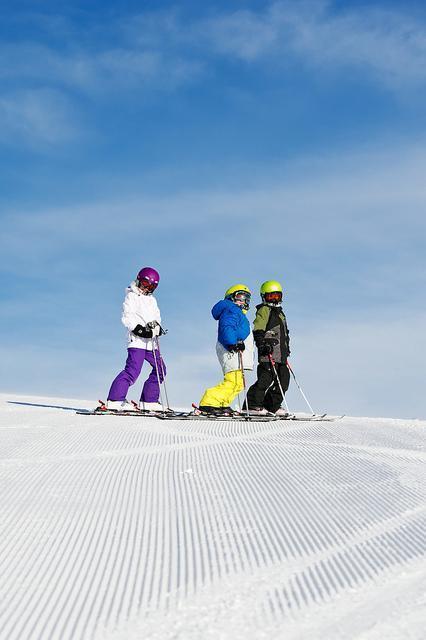How many people are there?
Give a very brief answer. 3. How many people are wearing black pants?
Give a very brief answer. 1. How many people are in the photo?
Give a very brief answer. 3. 